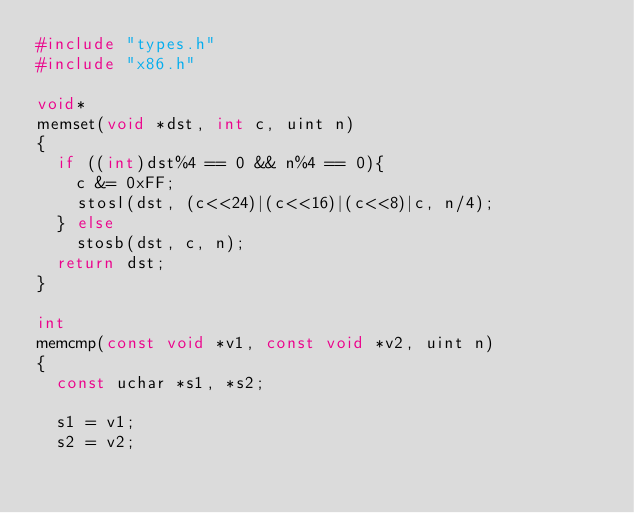Convert code to text. <code><loc_0><loc_0><loc_500><loc_500><_C_>#include "types.h"
#include "x86.h"

void*
memset(void *dst, int c, uint n)
{
  if ((int)dst%4 == 0 && n%4 == 0){
    c &= 0xFF;
    stosl(dst, (c<<24)|(c<<16)|(c<<8)|c, n/4);
  } else
    stosb(dst, c, n);
  return dst;
}

int
memcmp(const void *v1, const void *v2, uint n)
{
  const uchar *s1, *s2;

  s1 = v1;
  s2 = v2;</code> 